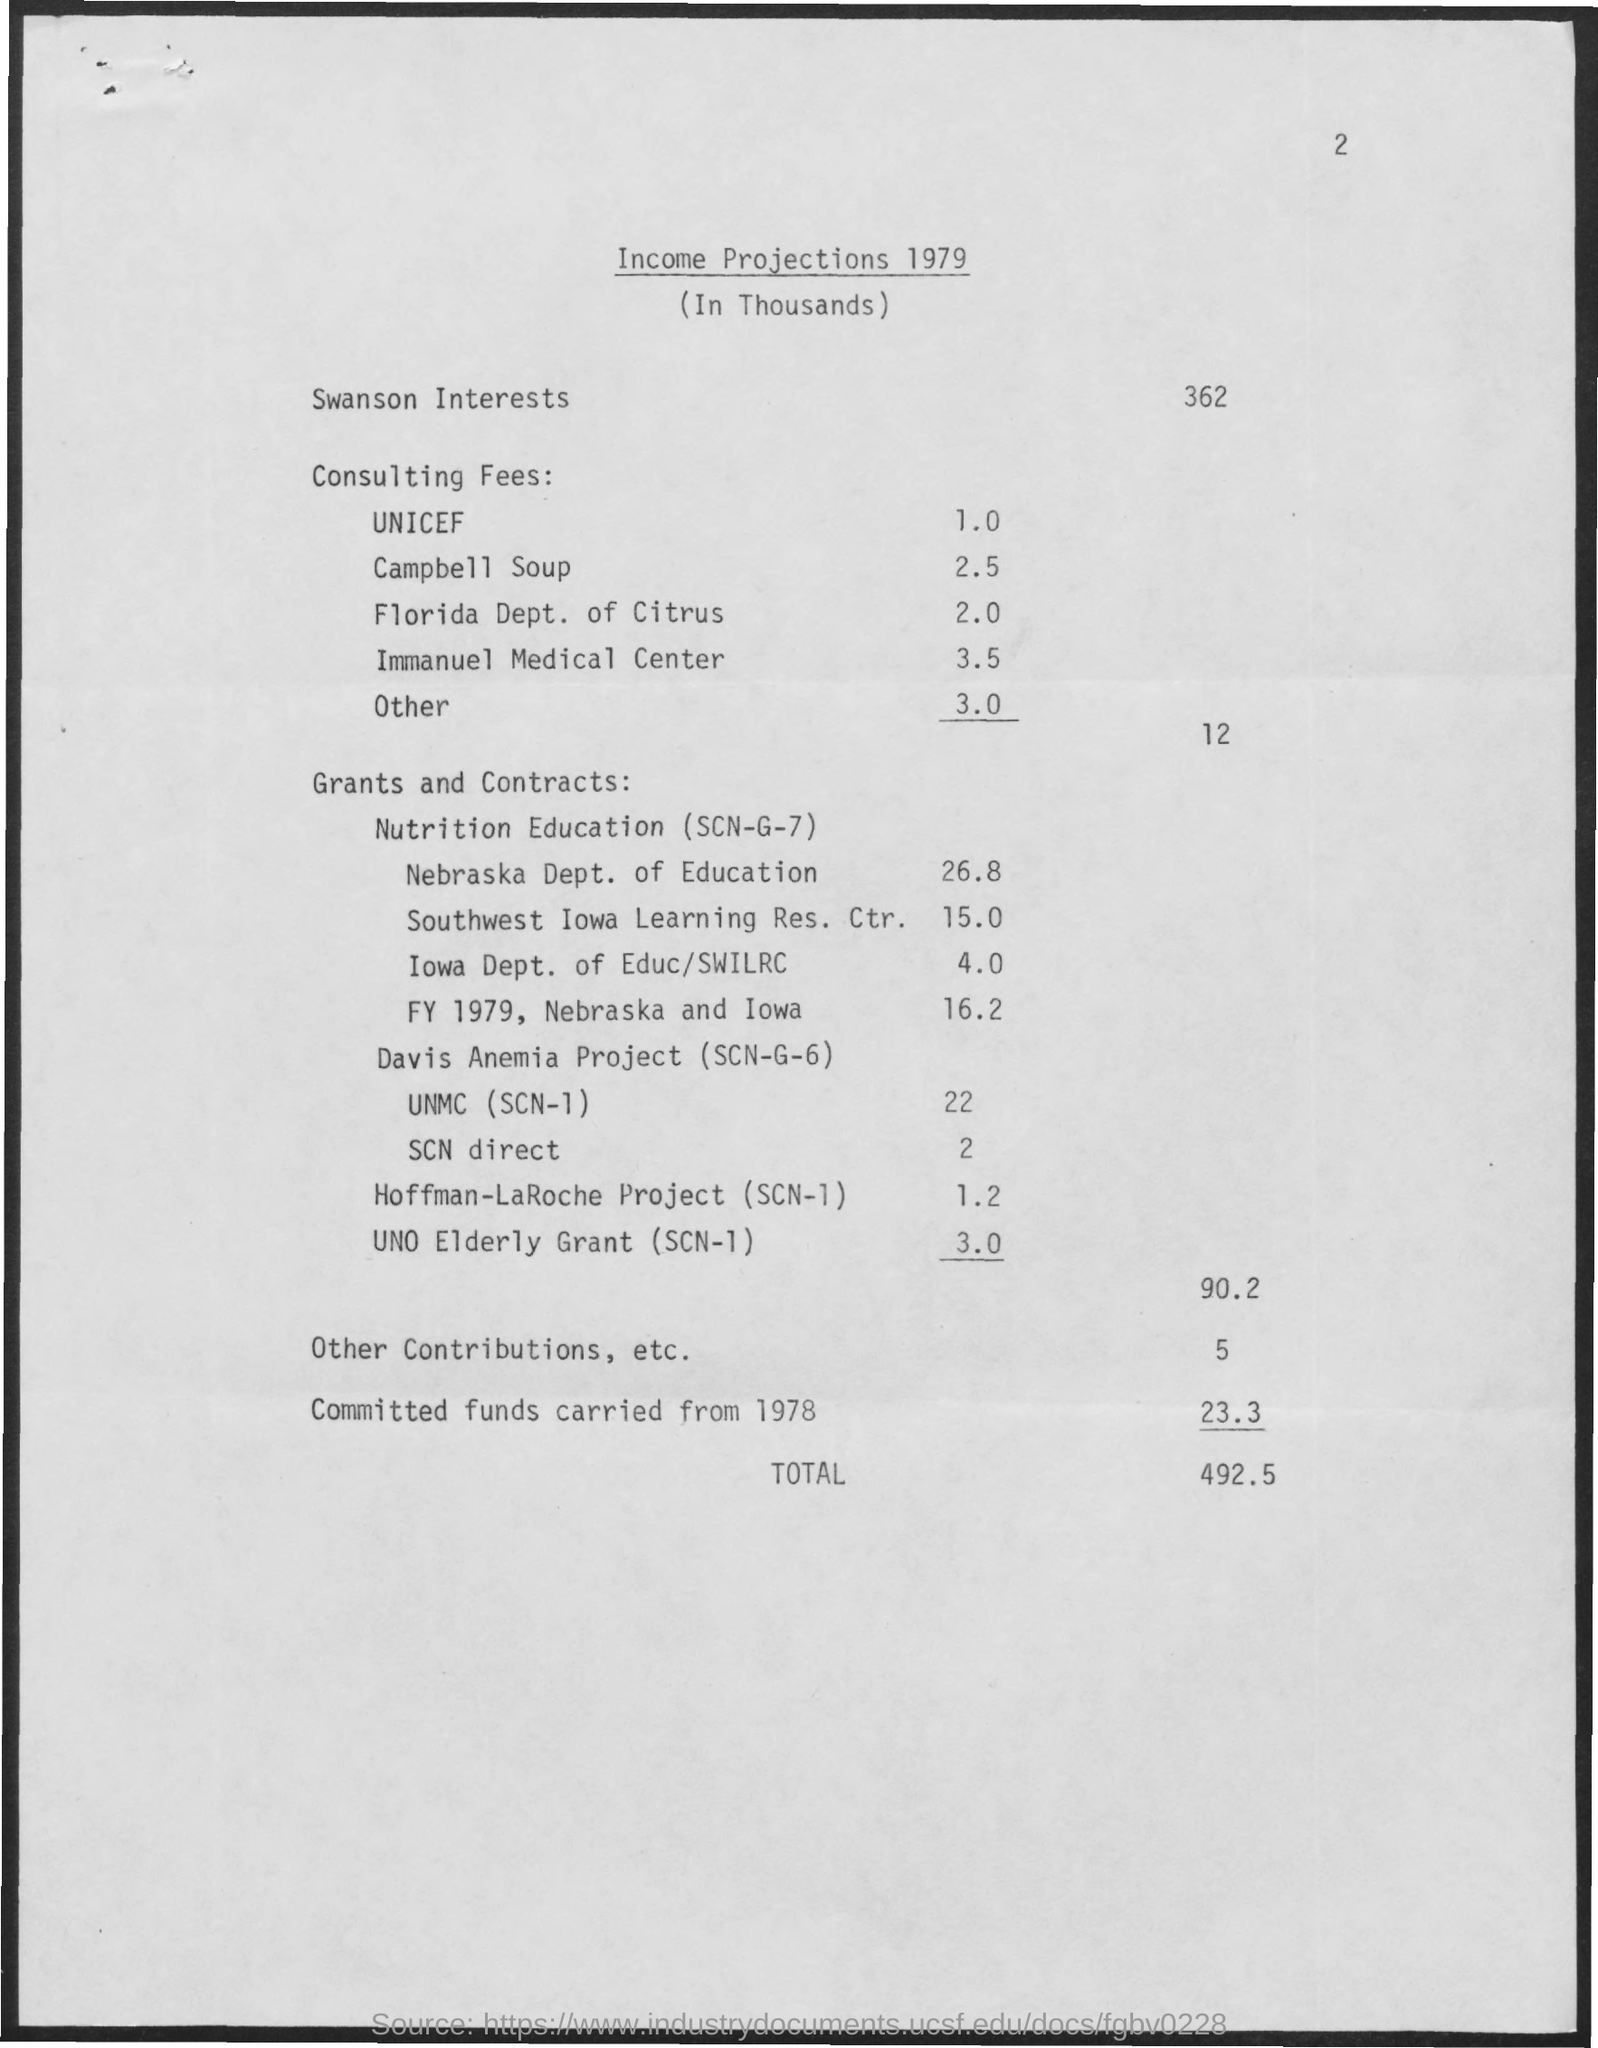Give some essential details in this illustration. The value of income for the Nebraska Department of Education is $26.8 million. The value of Campbell Soup is 2.5. The total value mentioned is 492.5... 